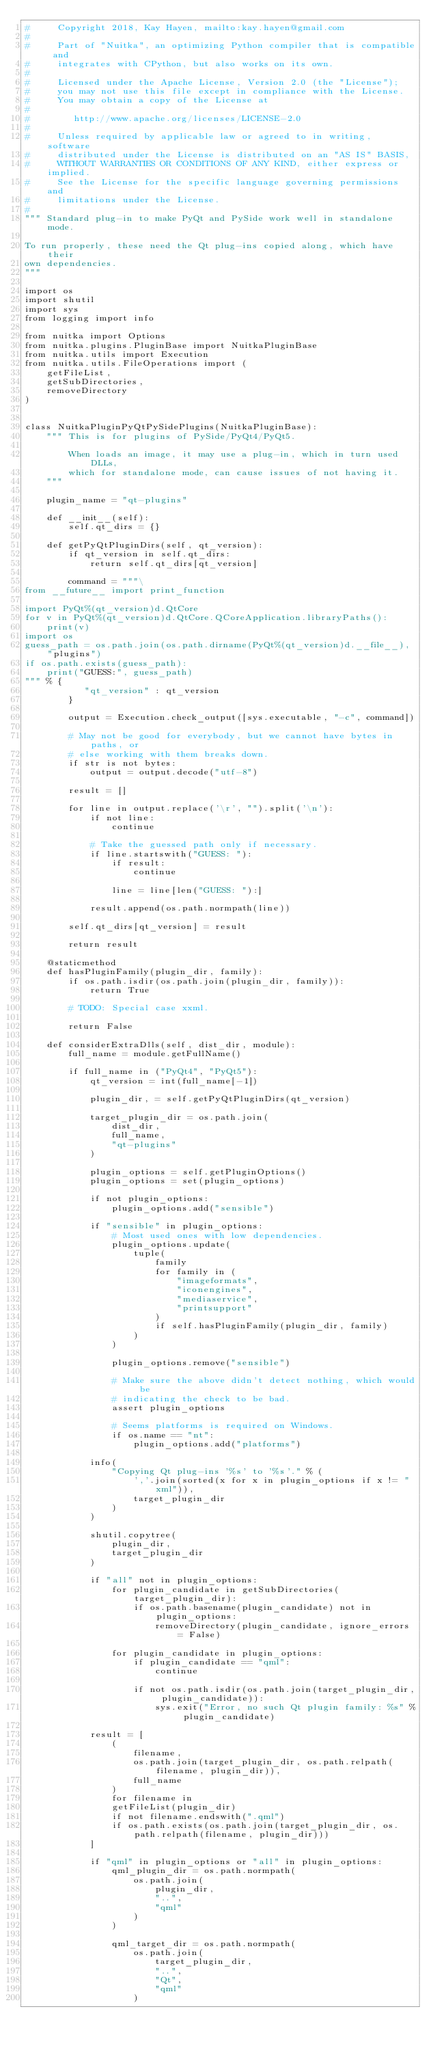Convert code to text. <code><loc_0><loc_0><loc_500><loc_500><_Python_>#     Copyright 2018, Kay Hayen, mailto:kay.hayen@gmail.com
#
#     Part of "Nuitka", an optimizing Python compiler that is compatible and
#     integrates with CPython, but also works on its own.
#
#     Licensed under the Apache License, Version 2.0 (the "License");
#     you may not use this file except in compliance with the License.
#     You may obtain a copy of the License at
#
#        http://www.apache.org/licenses/LICENSE-2.0
#
#     Unless required by applicable law or agreed to in writing, software
#     distributed under the License is distributed on an "AS IS" BASIS,
#     WITHOUT WARRANTIES OR CONDITIONS OF ANY KIND, either express or implied.
#     See the License for the specific language governing permissions and
#     limitations under the License.
#
""" Standard plug-in to make PyQt and PySide work well in standalone mode.

To run properly, these need the Qt plug-ins copied along, which have their
own dependencies.
"""

import os
import shutil
import sys
from logging import info

from nuitka import Options
from nuitka.plugins.PluginBase import NuitkaPluginBase
from nuitka.utils import Execution
from nuitka.utils.FileOperations import (
    getFileList,
    getSubDirectories,
    removeDirectory
)


class NuitkaPluginPyQtPySidePlugins(NuitkaPluginBase):
    """ This is for plugins of PySide/PyQt4/PyQt5.

        When loads an image, it may use a plug-in, which in turn used DLLs,
        which for standalone mode, can cause issues of not having it.
    """

    plugin_name = "qt-plugins"

    def __init__(self):
        self.qt_dirs = {}

    def getPyQtPluginDirs(self, qt_version):
        if qt_version in self.qt_dirs:
            return self.qt_dirs[qt_version]

        command = """\
from __future__ import print_function

import PyQt%(qt_version)d.QtCore
for v in PyQt%(qt_version)d.QtCore.QCoreApplication.libraryPaths():
    print(v)
import os
guess_path = os.path.join(os.path.dirname(PyQt%(qt_version)d.__file__), "plugins")
if os.path.exists(guess_path):
    print("GUESS:", guess_path)
""" % {
           "qt_version" : qt_version
        }

        output = Execution.check_output([sys.executable, "-c", command])

        # May not be good for everybody, but we cannot have bytes in paths, or
        # else working with them breaks down.
        if str is not bytes:
            output = output.decode("utf-8")

        result = []

        for line in output.replace('\r', "").split('\n'):
            if not line:
                continue

            # Take the guessed path only if necessary.
            if line.startswith("GUESS: "):
                if result:
                    continue

                line = line[len("GUESS: "):]

            result.append(os.path.normpath(line))

        self.qt_dirs[qt_version] = result

        return result

    @staticmethod
    def hasPluginFamily(plugin_dir, family):
        if os.path.isdir(os.path.join(plugin_dir, family)):
            return True

        # TODO: Special case xxml.

        return False

    def considerExtraDlls(self, dist_dir, module):
        full_name = module.getFullName()

        if full_name in ("PyQt4", "PyQt5"):
            qt_version = int(full_name[-1])

            plugin_dir, = self.getPyQtPluginDirs(qt_version)

            target_plugin_dir = os.path.join(
                dist_dir,
                full_name,
                "qt-plugins"
            )

            plugin_options = self.getPluginOptions()
            plugin_options = set(plugin_options)

            if not plugin_options:
                plugin_options.add("sensible")

            if "sensible" in plugin_options:
                # Most used ones with low dependencies.
                plugin_options.update(
                    tuple(
                        family
                        for family in (
                            "imageformats",
                            "iconengines",
                            "mediaservice",
                            "printsupport"
                        )
                        if self.hasPluginFamily(plugin_dir, family)
                    )
                )

                plugin_options.remove("sensible")

                # Make sure the above didn't detect nothing, which would be
                # indicating the check to be bad.
                assert plugin_options

                # Seems platforms is required on Windows.
                if os.name == "nt":
                    plugin_options.add("platforms")

            info(
                "Copying Qt plug-ins '%s' to '%s'." % (
                    ','.join(sorted(x for x in plugin_options if x != "xml")),
                    target_plugin_dir
                )
            )

            shutil.copytree(
                plugin_dir,
                target_plugin_dir
            )

            if "all" not in plugin_options:
                for plugin_candidate in getSubDirectories(target_plugin_dir):
                    if os.path.basename(plugin_candidate) not in plugin_options:
                        removeDirectory(plugin_candidate, ignore_errors = False)

                for plugin_candidate in plugin_options:
                    if plugin_candidate == "qml":
                        continue

                    if not os.path.isdir(os.path.join(target_plugin_dir, plugin_candidate)):
                        sys.exit("Error, no such Qt plugin family: %s" % plugin_candidate)

            result = [
                (
                    filename,
                    os.path.join(target_plugin_dir, os.path.relpath(filename, plugin_dir)),
                    full_name
                )
                for filename in
                getFileList(plugin_dir)
                if not filename.endswith(".qml")
                if os.path.exists(os.path.join(target_plugin_dir, os.path.relpath(filename, plugin_dir)))
            ]

            if "qml" in plugin_options or "all" in plugin_options:
                qml_plugin_dir = os.path.normpath(
                    os.path.join(
                        plugin_dir,
                        "..",
                        "qml"
                    )
                )

                qml_target_dir = os.path.normpath(
                    os.path.join(
                        target_plugin_dir,
                        "..",
                        "Qt",
                        "qml"
                    )</code> 